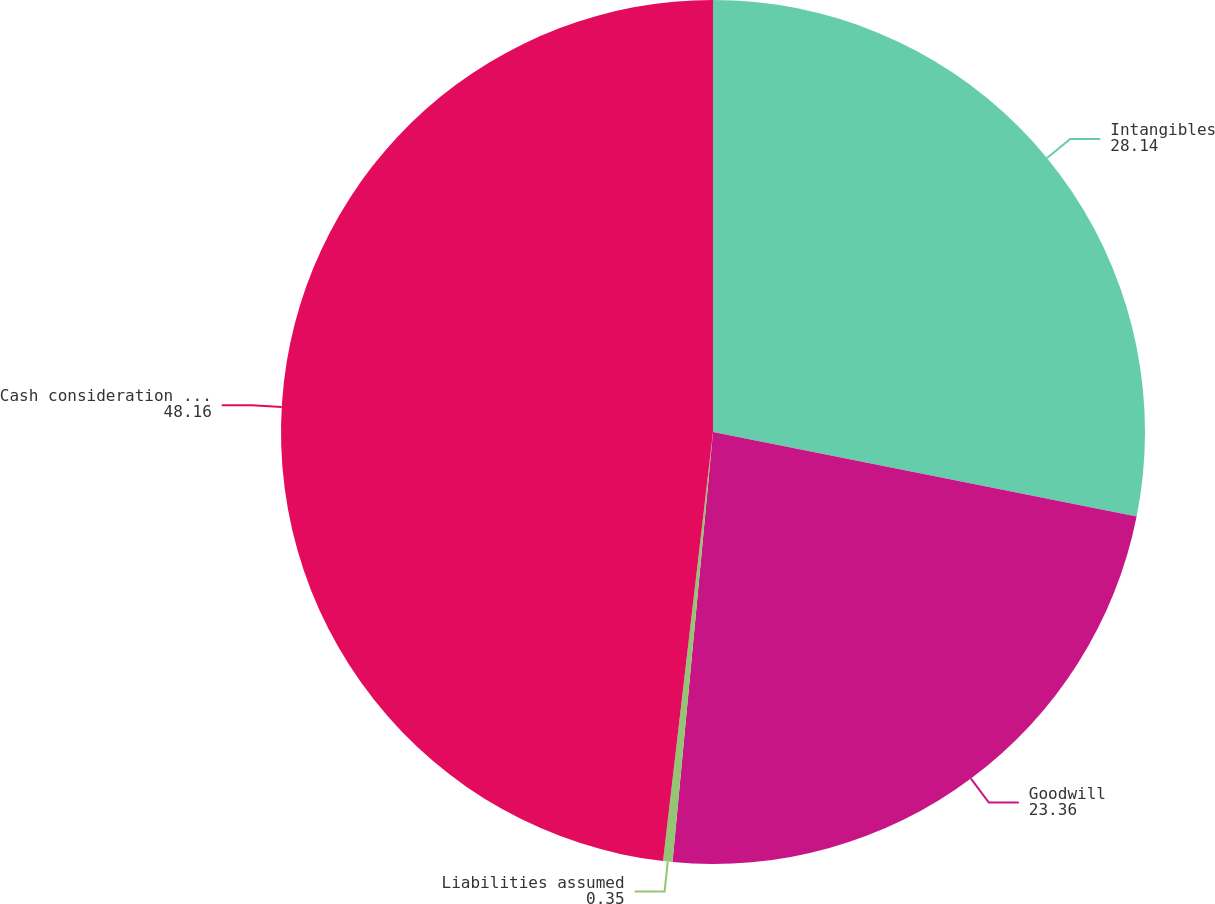Convert chart to OTSL. <chart><loc_0><loc_0><loc_500><loc_500><pie_chart><fcel>Intangibles<fcel>Goodwill<fcel>Liabilities assumed<fcel>Cash consideration paid<nl><fcel>28.14%<fcel>23.36%<fcel>0.35%<fcel>48.16%<nl></chart> 